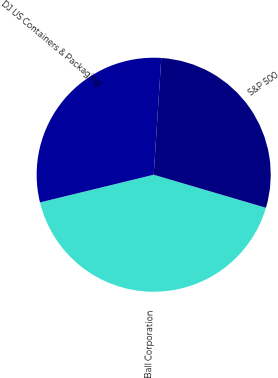<chart> <loc_0><loc_0><loc_500><loc_500><pie_chart><fcel>Ball Corporation<fcel>DJ US Containers & Packaging<fcel>S&P 500<nl><fcel>41.64%<fcel>29.83%<fcel>28.52%<nl></chart> 